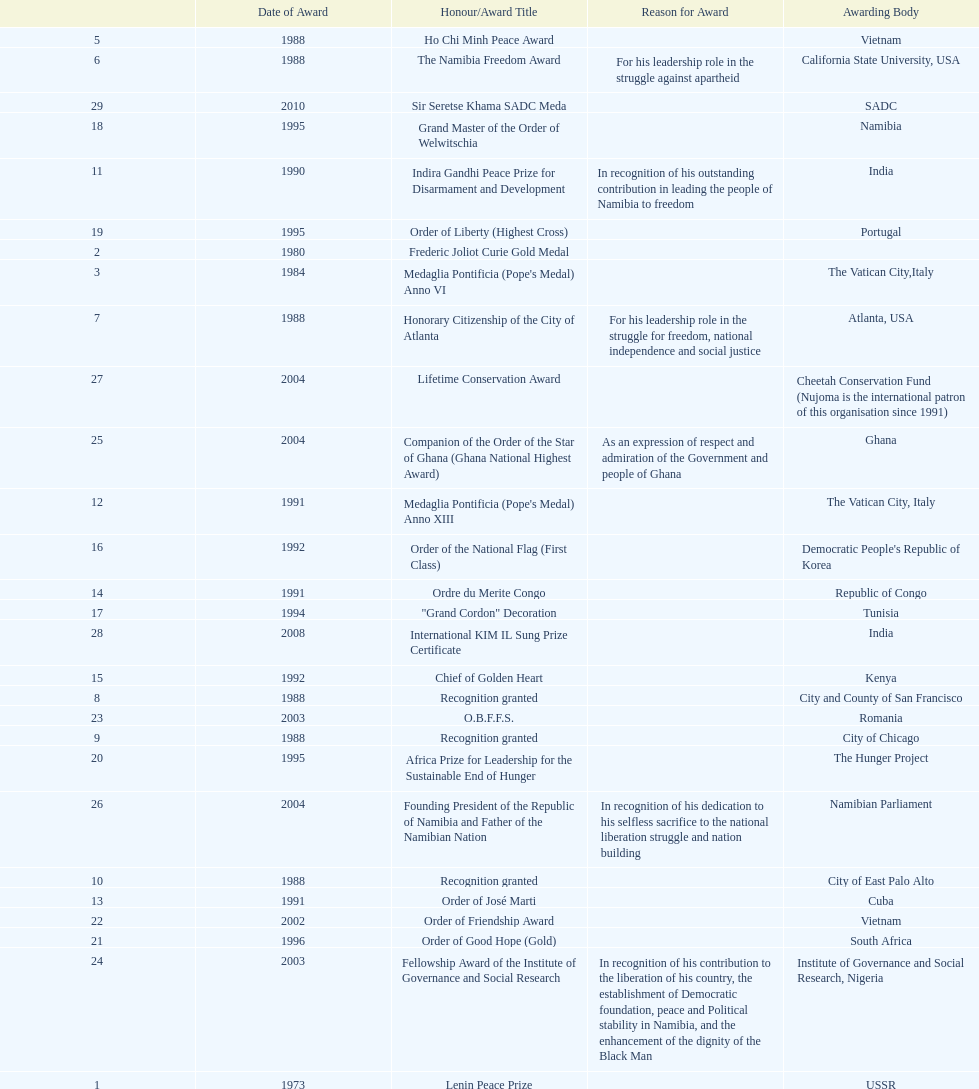Which year was the most honors/award titles given? 1988. 